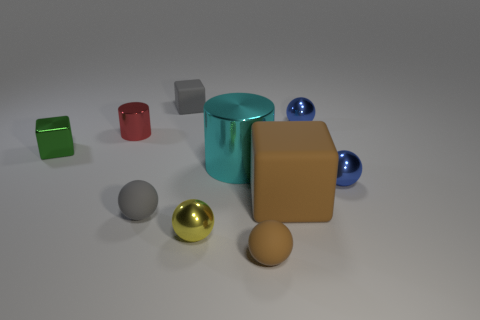What is the size of the metal ball that is in front of the small green thing and right of the yellow ball?
Your response must be concise. Small. What shape is the green object?
Provide a short and direct response. Cube. Is there a red cylinder that is left of the small metallic sphere that is on the left side of the large brown thing?
Provide a succinct answer. Yes. What material is the yellow ball that is the same size as the shiny block?
Offer a very short reply. Metal. Are there any other red cylinders of the same size as the red cylinder?
Your response must be concise. No. There is a blue ball in front of the cyan object; what material is it?
Your answer should be very brief. Metal. Do the small cube that is right of the gray ball and the large block have the same material?
Your answer should be very brief. Yes. The brown matte thing that is the same size as the red metallic cylinder is what shape?
Ensure brevity in your answer.  Sphere. What number of tiny cylinders are the same color as the big matte cube?
Your answer should be compact. 0. Is the number of brown objects behind the brown block less than the number of large brown objects in front of the small brown thing?
Give a very brief answer. No. 